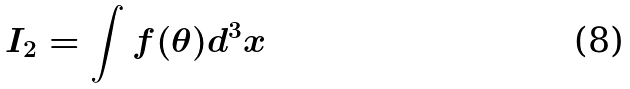<formula> <loc_0><loc_0><loc_500><loc_500>I _ { 2 } = \int f ( \theta ) d ^ { 3 } x</formula> 